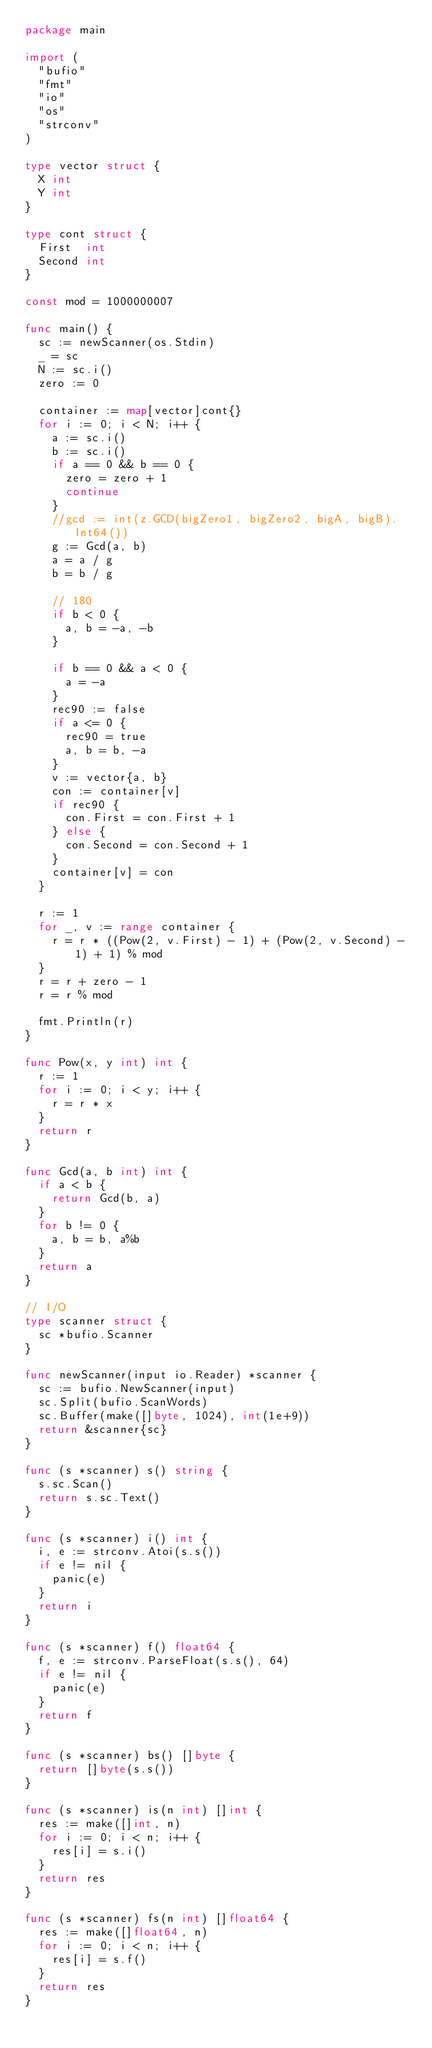<code> <loc_0><loc_0><loc_500><loc_500><_Go_>package main

import (
	"bufio"
	"fmt"
	"io"
	"os"
	"strconv"
)

type vector struct {
	X int
	Y int
}

type cont struct {
	First  int
	Second int
}

const mod = 1000000007

func main() {
	sc := newScanner(os.Stdin)
	_ = sc
	N := sc.i()
	zero := 0

	container := map[vector]cont{}
	for i := 0; i < N; i++ {
		a := sc.i()
		b := sc.i()
		if a == 0 && b == 0 {
			zero = zero + 1
			continue
		}
		//gcd := int(z.GCD(bigZero1, bigZero2, bigA, bigB).Int64())
		g := Gcd(a, b)
		a = a / g
		b = b / g

		// 180
		if b < 0 {
			a, b = -a, -b
		}
		
		if b == 0 && a < 0 {
			a = -a
		}
		rec90 := false
		if a <= 0 {
			rec90 = true
			a, b = b, -a
		}
		v := vector{a, b}
		con := container[v]
		if rec90 {
			con.First = con.First + 1
		} else {
			con.Second = con.Second + 1
		}
		container[v] = con
	}

	r := 1
	for _, v := range container {
		r = r * ((Pow(2, v.First) - 1) + (Pow(2, v.Second) - 1) + 1) % mod
	}
	r = r + zero - 1
	r = r % mod

	fmt.Println(r)
}

func Pow(x, y int) int {
	r := 1
	for i := 0; i < y; i++ {
		r = r * x
	}
	return r
}

func Gcd(a, b int) int {
	if a < b {
		return Gcd(b, a)
	}
	for b != 0 {
		a, b = b, a%b
	}
	return a
}

// I/O
type scanner struct {
	sc *bufio.Scanner
}

func newScanner(input io.Reader) *scanner {
	sc := bufio.NewScanner(input)
	sc.Split(bufio.ScanWords)
	sc.Buffer(make([]byte, 1024), int(1e+9))
	return &scanner{sc}
}

func (s *scanner) s() string {
	s.sc.Scan()
	return s.sc.Text()
}

func (s *scanner) i() int {
	i, e := strconv.Atoi(s.s())
	if e != nil {
		panic(e)
	}
	return i
}

func (s *scanner) f() float64 {
	f, e := strconv.ParseFloat(s.s(), 64)
	if e != nil {
		panic(e)
	}
	return f
}

func (s *scanner) bs() []byte {
	return []byte(s.s())
}

func (s *scanner) is(n int) []int {
	res := make([]int, n)
	for i := 0; i < n; i++ {
		res[i] = s.i()
	}
	return res
}

func (s *scanner) fs(n int) []float64 {
	res := make([]float64, n)
	for i := 0; i < n; i++ {
		res[i] = s.f()
	}
	return res
}
</code> 